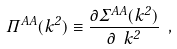Convert formula to latex. <formula><loc_0><loc_0><loc_500><loc_500>\Pi ^ { A A } ( k ^ { 2 } ) \equiv \frac { \partial \Sigma ^ { A A } ( k ^ { 2 } ) } { \partial \ k ^ { 2 } } \ ,</formula> 